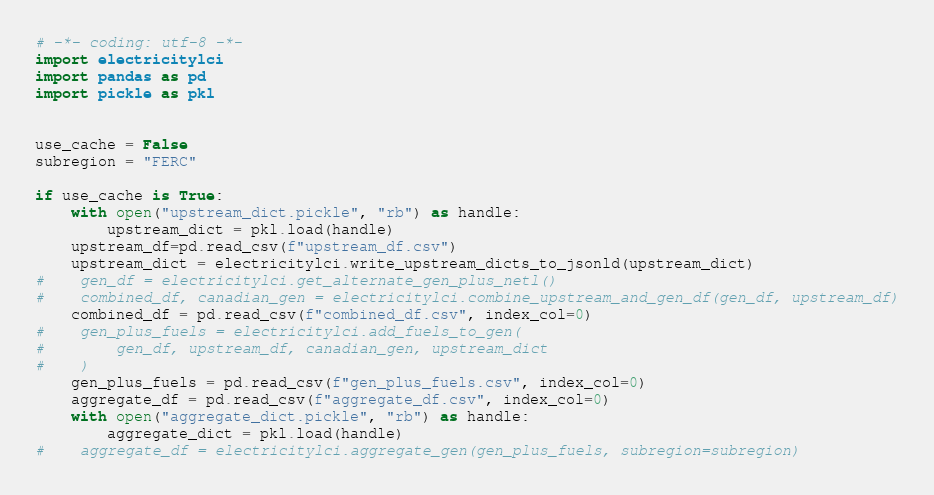Convert code to text. <code><loc_0><loc_0><loc_500><loc_500><_Python_># -*- coding: utf-8 -*-
import electricitylci
import pandas as pd
import pickle as pkl


use_cache = False
subregion = "FERC"

if use_cache is True:
    with open("upstream_dict.pickle", "rb") as handle:
        upstream_dict = pkl.load(handle)
    upstream_df=pd.read_csv(f"upstream_df.csv")
    upstream_dict = electricitylci.write_upstream_dicts_to_jsonld(upstream_dict)
#    gen_df = electricitylci.get_alternate_gen_plus_netl()
#    combined_df, canadian_gen = electricitylci.combine_upstream_and_gen_df(gen_df, upstream_df)
    combined_df = pd.read_csv(f"combined_df.csv", index_col=0)
#    gen_plus_fuels = electricitylci.add_fuels_to_gen(
#        gen_df, upstream_df, canadian_gen, upstream_dict
#    )
    gen_plus_fuels = pd.read_csv(f"gen_plus_fuels.csv", index_col=0)
    aggregate_df = pd.read_csv(f"aggregate_df.csv", index_col=0)
    with open("aggregate_dict.pickle", "rb") as handle:
        aggregate_dict = pkl.load(handle)
#    aggregate_df = electricitylci.aggregate_gen(gen_plus_fuels, subregion=subregion)</code> 